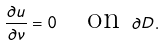Convert formula to latex. <formula><loc_0><loc_0><loc_500><loc_500>\frac { \partial u } { \partial \nu } = 0 \quad \text {on } \partial D .</formula> 